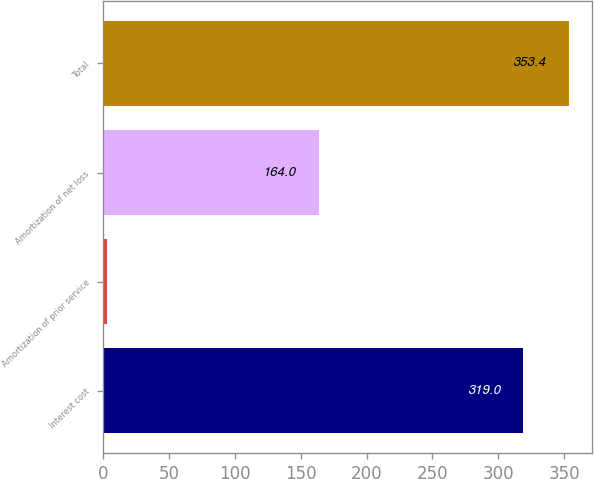Convert chart. <chart><loc_0><loc_0><loc_500><loc_500><bar_chart><fcel>Interest cost<fcel>Amortization of prior service<fcel>Amortization of net loss<fcel>Total<nl><fcel>319<fcel>3<fcel>164<fcel>353.4<nl></chart> 